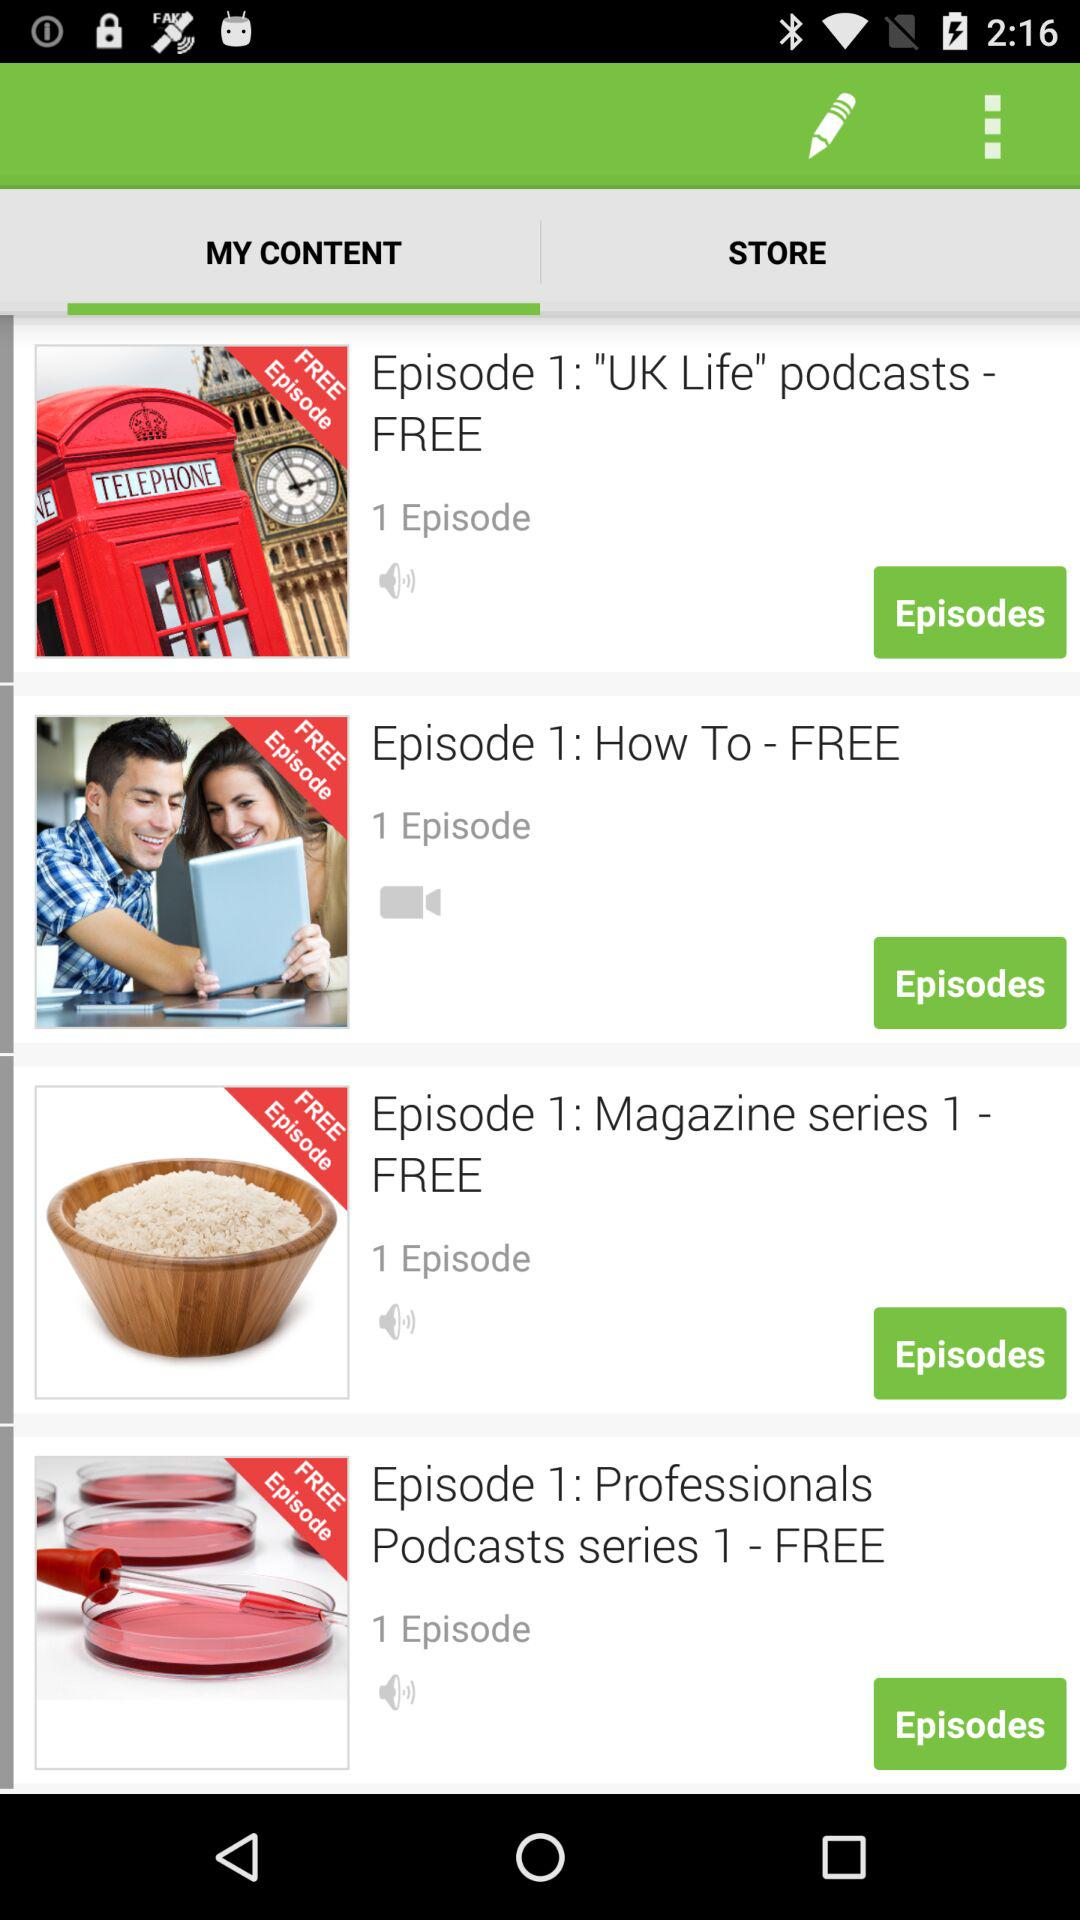What is the number of episodes in "Episode 1: Magazine series 1 - FREE"? The number of episodes in "Episode 1: Magazine series 1 - FREE" is 1. 